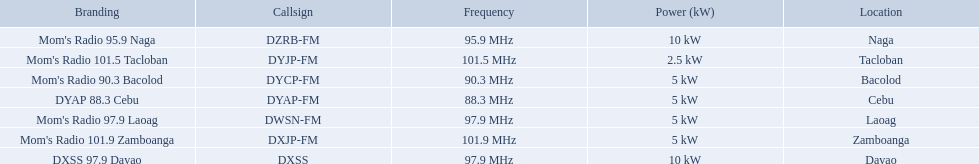Which stations use less than 10kw of power? Mom's Radio 97.9 Laoag, Mom's Radio 90.3 Bacolod, DYAP 88.3 Cebu, Mom's Radio 101.5 Tacloban, Mom's Radio 101.9 Zamboanga. Do any stations use less than 5kw of power? if so, which ones? Mom's Radio 101.5 Tacloban. 